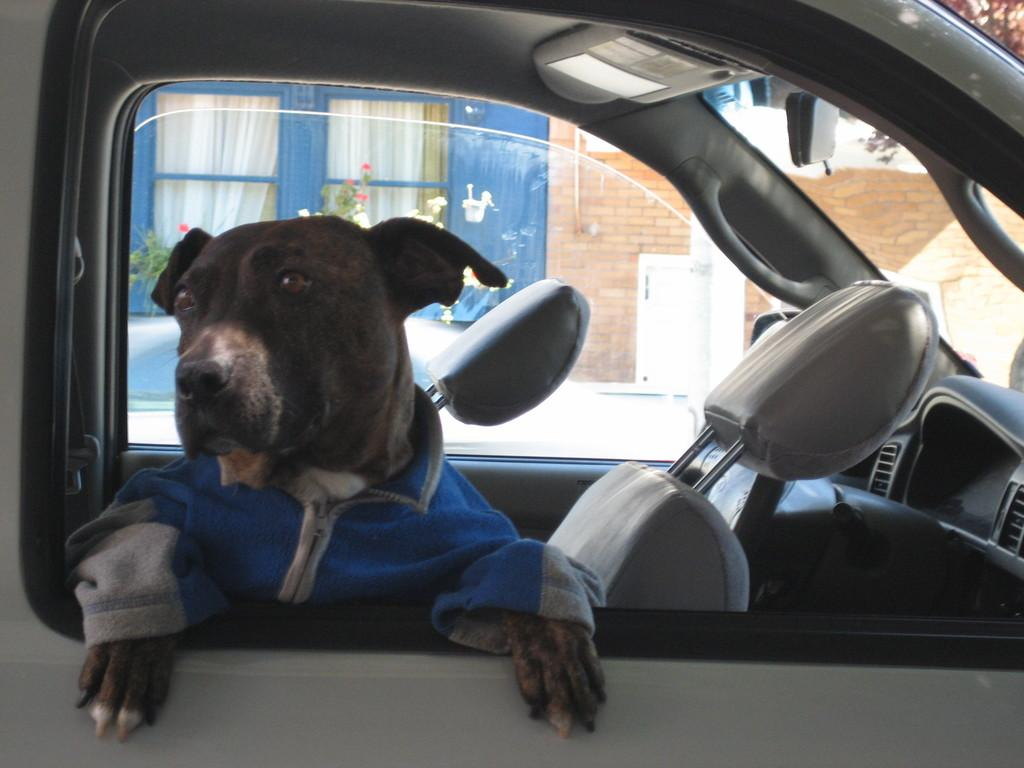What type of animal is inside the vehicle in the image? There is a dog in the vehicle in the image. Where is the vehicle located in the image? The vehicle is in the middle of the image. What can be seen behind the vehicle? There are plants behind the vehicle. What type of structure is visible in the image? There is a building visible in the image. What type of insurance does the dog have for its trip in the vehicle? There is no information about insurance for the dog in the image. --- 